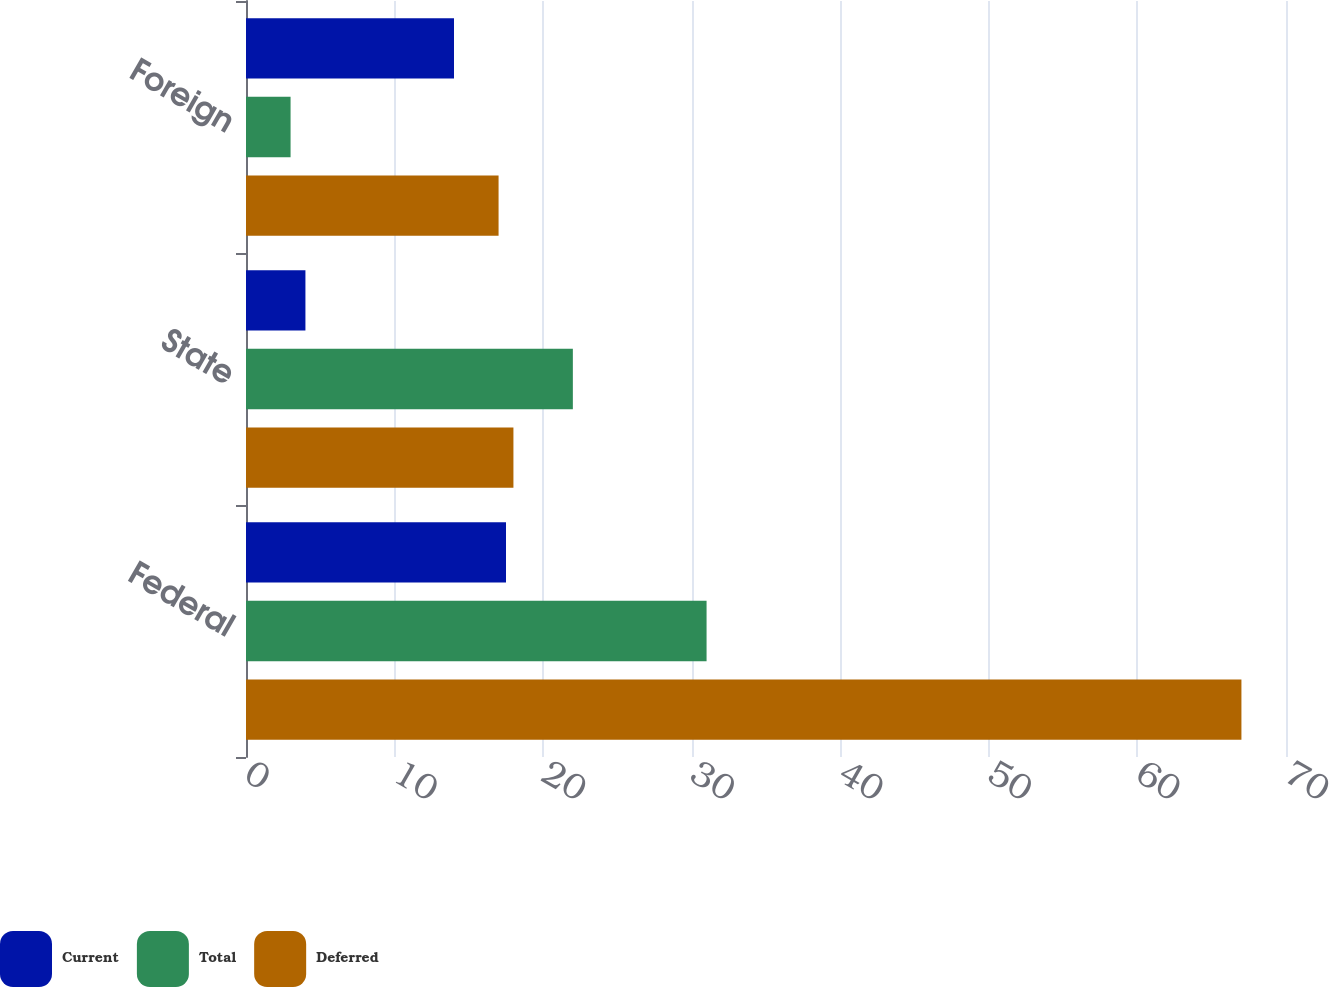Convert chart to OTSL. <chart><loc_0><loc_0><loc_500><loc_500><stacked_bar_chart><ecel><fcel>Federal<fcel>State<fcel>Foreign<nl><fcel>Current<fcel>17.5<fcel>4<fcel>14<nl><fcel>Total<fcel>31<fcel>22<fcel>3<nl><fcel>Deferred<fcel>67<fcel>18<fcel>17<nl></chart> 